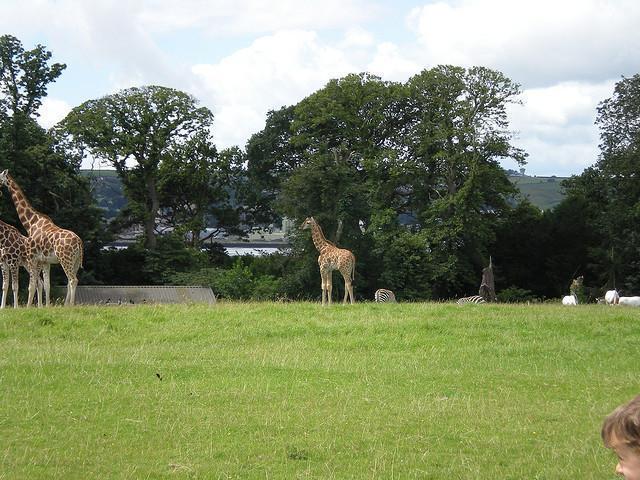What are the zebras doing?
Indicate the correct response by choosing from the four available options to answer the question.
Options: Feeding, bathing, attacking giraffes, grooming. Feeding. 